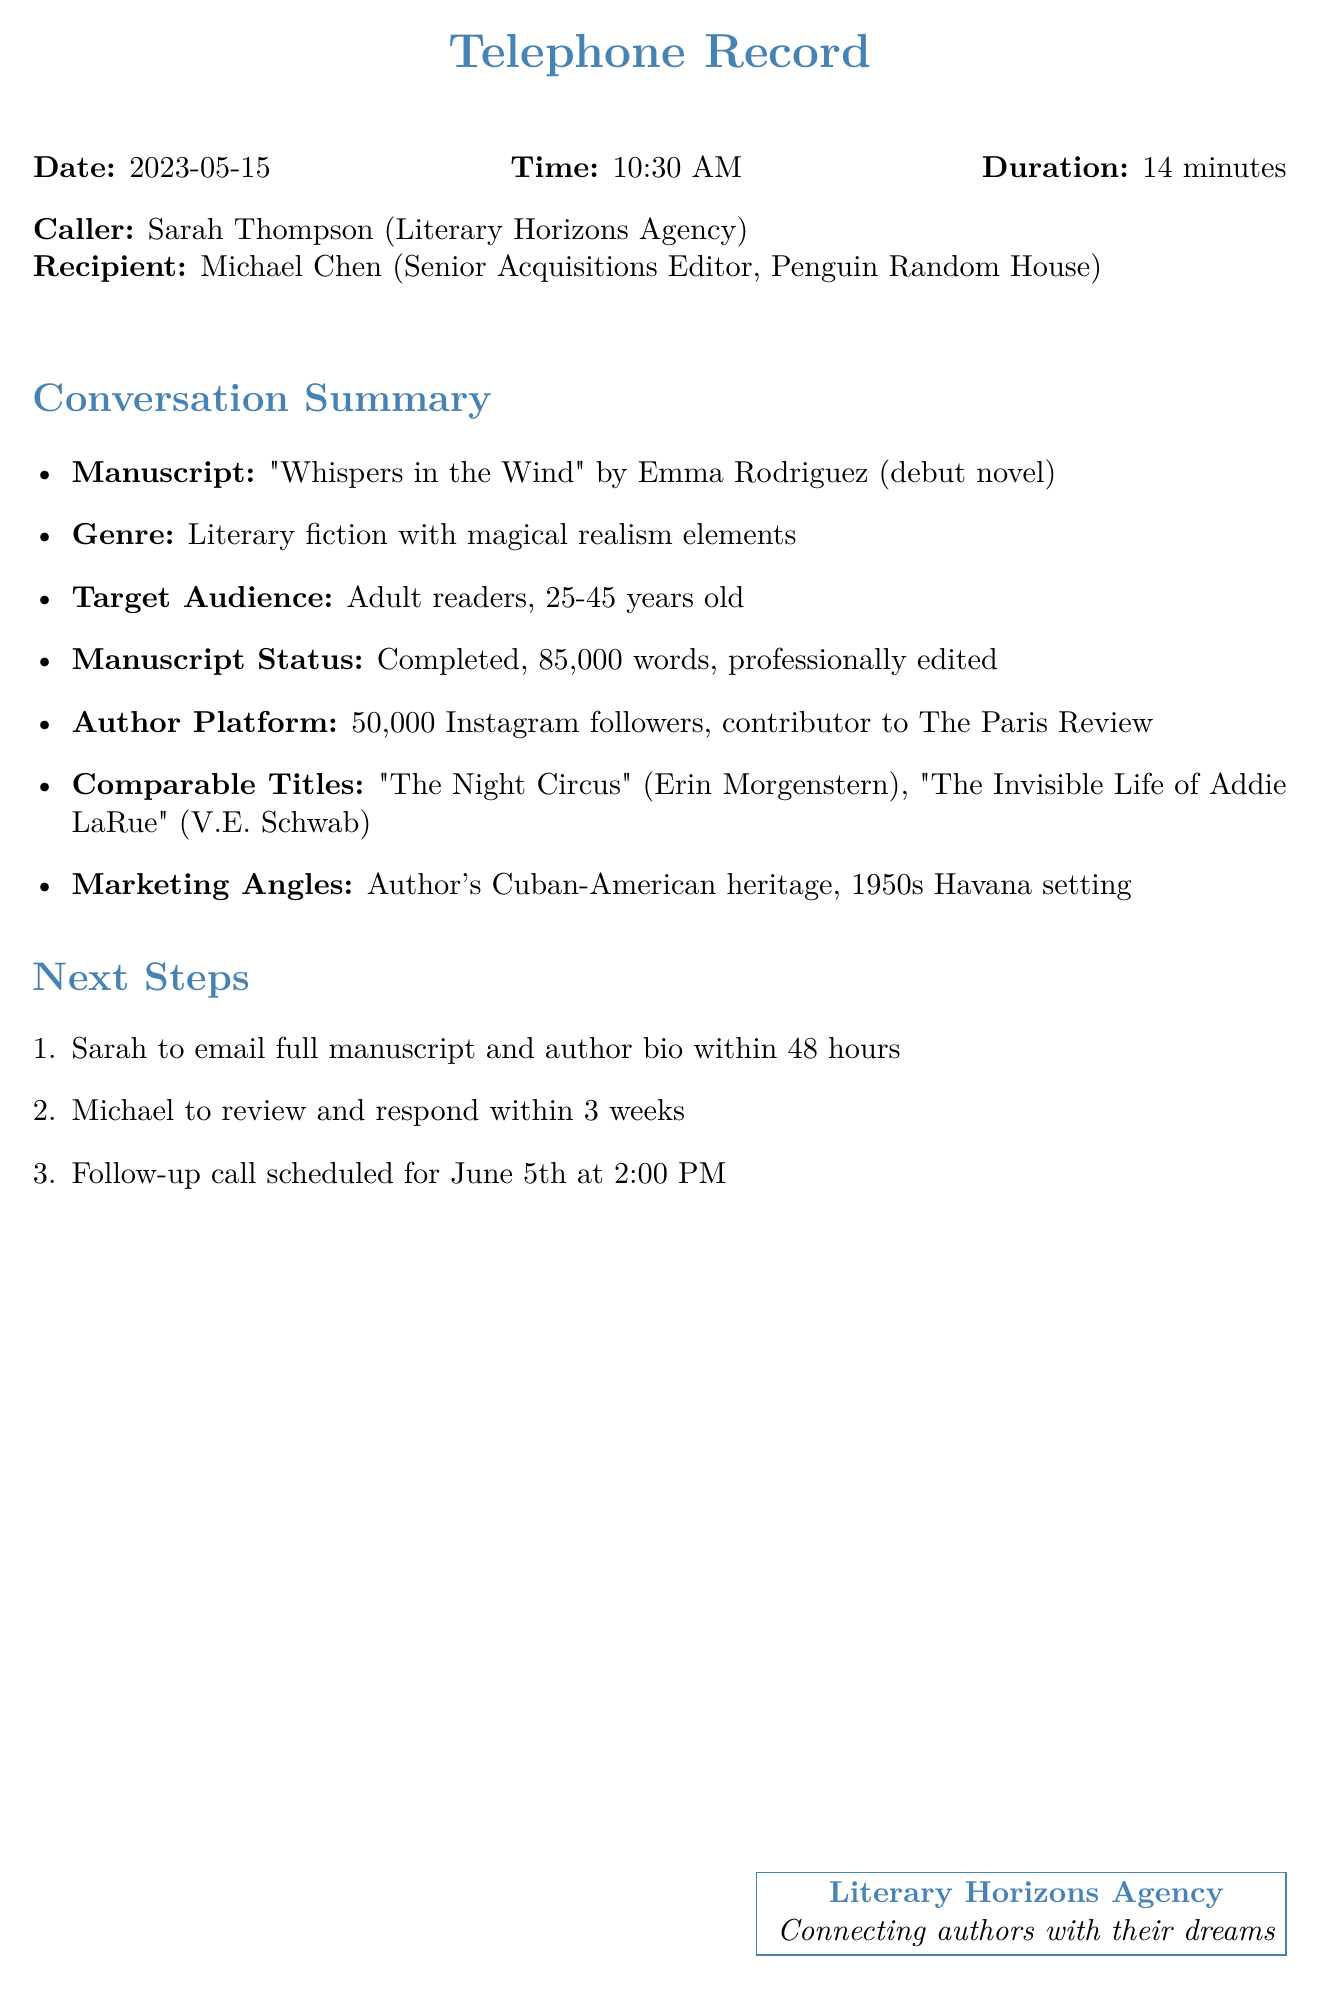What is the date of the call? The date of the call is specified at the beginning of the document.
Answer: 2023-05-15 Who is the author of the manuscript? The author's name is mentioned in the conversation summary section of the document.
Answer: Emma Rodriguez What genre does the manuscript belong to? The genre is listed in the conversation summary.
Answer: Literary fiction with magical realism elements How many words is the manuscript? The document specifies the manuscript's length in the conversation summary.
Answer: 85,000 words What is the author's platform size? The document provides information about the author's social media following.
Answer: 50,000 Instagram followers What are the comparable titles mentioned? The document lists comparable titles to provide context for the manuscript.
Answer: "The Night Circus," "The Invisible Life of Addie LaRue" What is the target audience age range? The target audience is stated in the conversation summary section.
Answer: 25-45 years old What is the follow-up call date? The follow-up call date is outlined in the next steps of the document.
Answer: June 5th at 2:00 PM Who is the caller in the conversation? The caller's name is given at the beginning of the document.
Answer: Sarah Thompson 